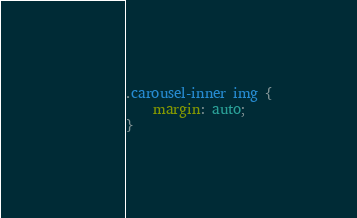Convert code to text. <code><loc_0><loc_0><loc_500><loc_500><_CSS_>.carousel-inner img {
    margin: auto;
}</code> 